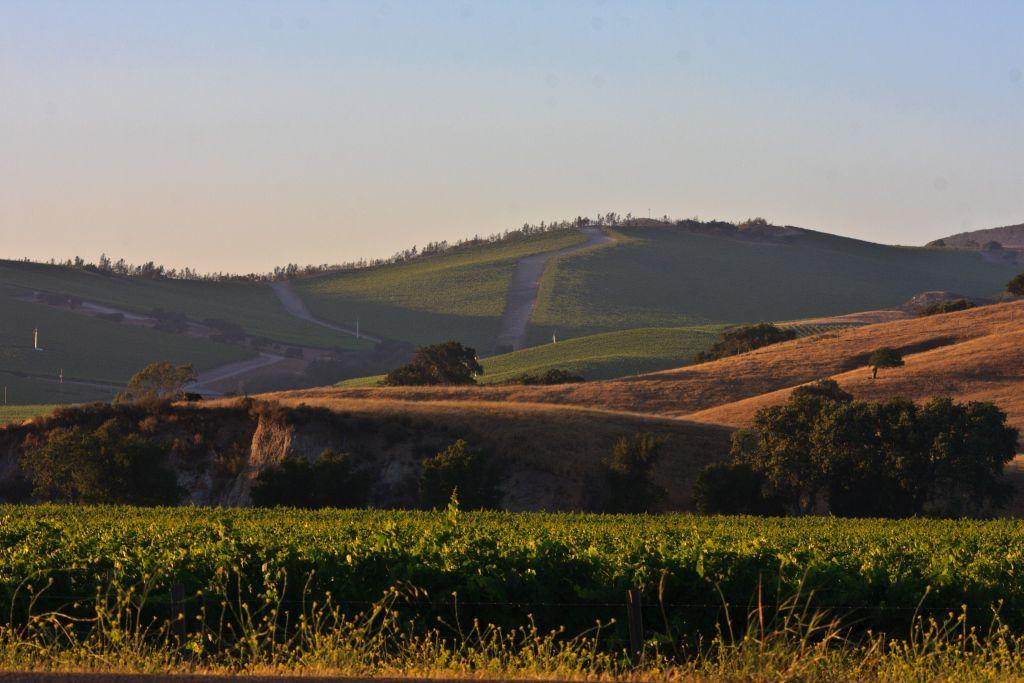What type of natural landscape can be seen in the image? There are hills in the image. What type of vegetation is present in the image? There are trees and plants in the image. What is visible in the background of the image? The sky is visible in the image. Where is the glove located in the image? There is no glove present in the image. What type of bun is being prepared in the image? There is no bun or any food preparation visible in the image. 